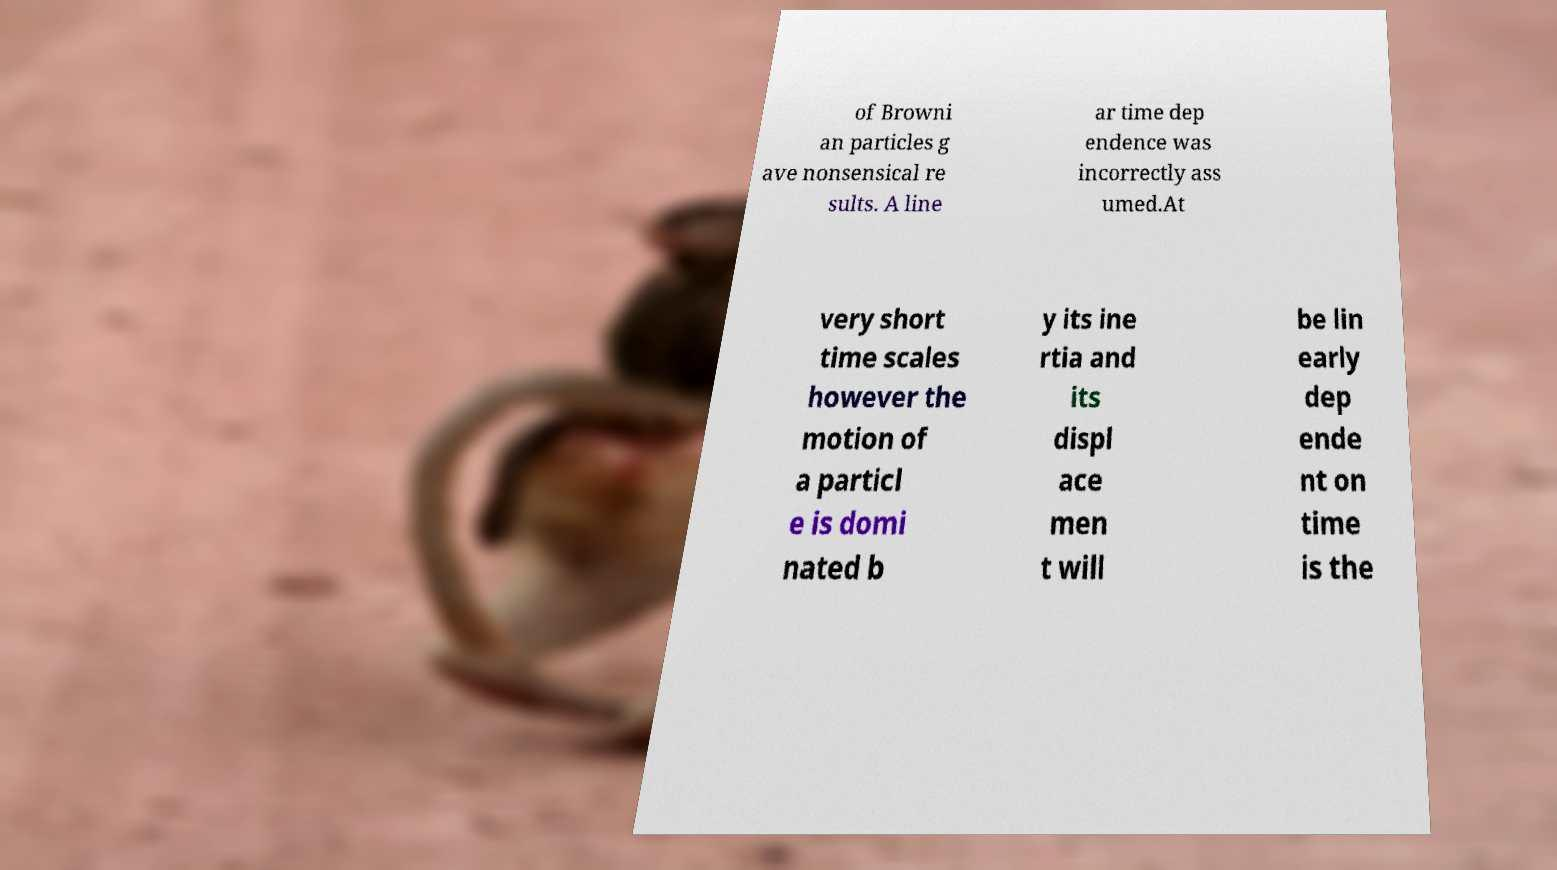There's text embedded in this image that I need extracted. Can you transcribe it verbatim? of Browni an particles g ave nonsensical re sults. A line ar time dep endence was incorrectly ass umed.At very short time scales however the motion of a particl e is domi nated b y its ine rtia and its displ ace men t will be lin early dep ende nt on time is the 